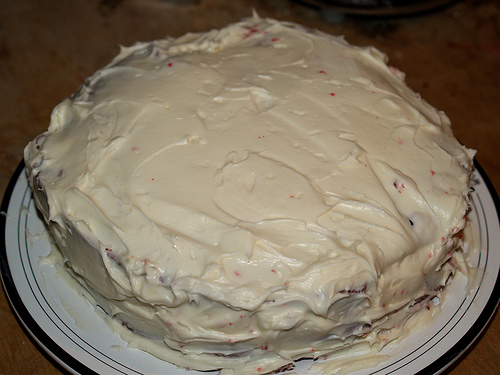<image>
Is there a cake next to the plate? No. The cake is not positioned next to the plate. They are located in different areas of the scene. 